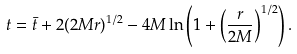Convert formula to latex. <formula><loc_0><loc_0><loc_500><loc_500>t = \bar { t } + 2 ( 2 M r ) ^ { 1 / 2 } - 4 M \ln \left ( 1 + \left ( \frac { r } { 2 M } \right ) ^ { 1 / 2 } \right ) .</formula> 